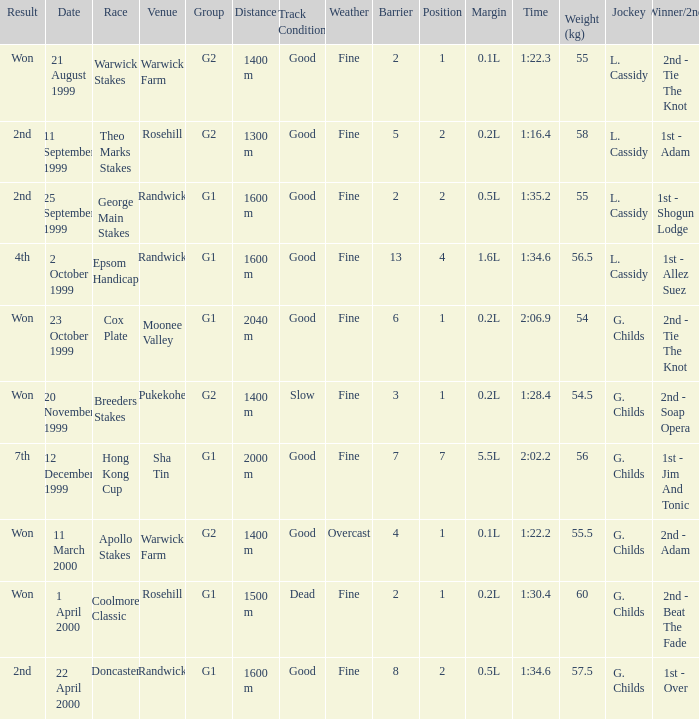List the weight for 56.5 kilograms. Epsom Handicap. 